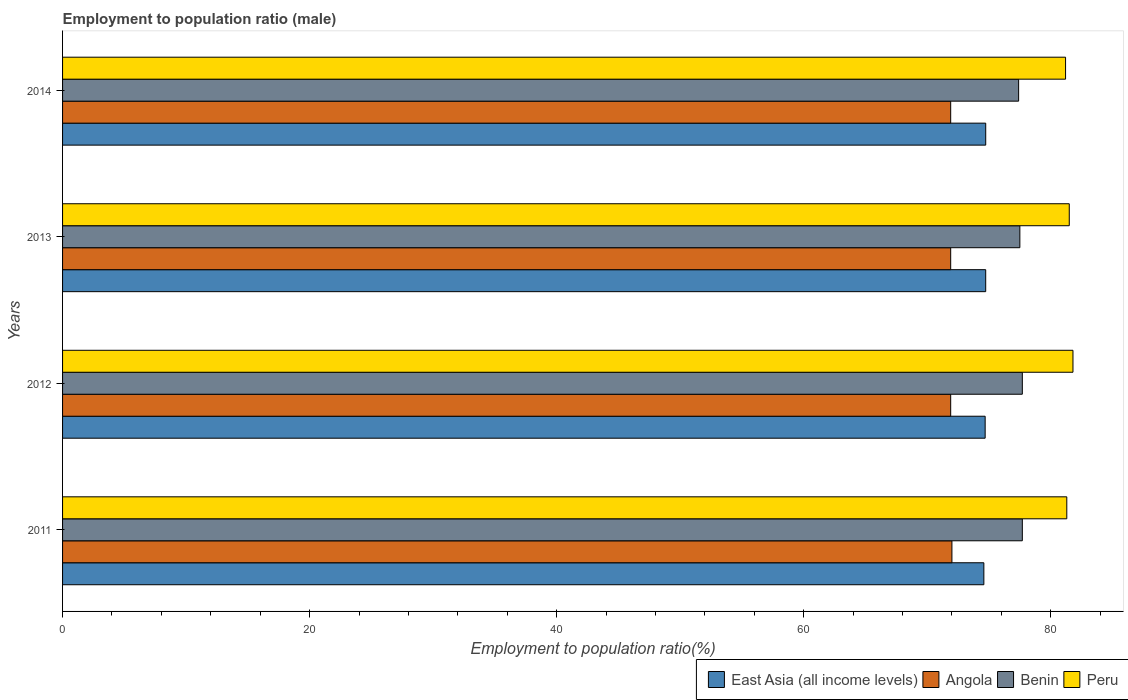What is the label of the 2nd group of bars from the top?
Your response must be concise. 2013. In how many cases, is the number of bars for a given year not equal to the number of legend labels?
Your response must be concise. 0. What is the employment to population ratio in Benin in 2014?
Give a very brief answer. 77.4. Across all years, what is the minimum employment to population ratio in Benin?
Provide a succinct answer. 77.4. In which year was the employment to population ratio in Benin maximum?
Provide a short and direct response. 2011. What is the total employment to population ratio in Peru in the graph?
Provide a succinct answer. 325.8. What is the difference between the employment to population ratio in East Asia (all income levels) in 2011 and that in 2013?
Provide a short and direct response. -0.15. What is the difference between the employment to population ratio in Angola in 2011 and the employment to population ratio in East Asia (all income levels) in 2012?
Give a very brief answer. -2.69. What is the average employment to population ratio in Angola per year?
Provide a succinct answer. 71.93. In the year 2012, what is the difference between the employment to population ratio in Peru and employment to population ratio in Angola?
Make the answer very short. 9.9. In how many years, is the employment to population ratio in Benin greater than 20 %?
Ensure brevity in your answer.  4. What is the difference between the highest and the second highest employment to population ratio in Peru?
Keep it short and to the point. 0.3. What is the difference between the highest and the lowest employment to population ratio in Angola?
Give a very brief answer. 0.1. Is the sum of the employment to population ratio in Benin in 2011 and 2013 greater than the maximum employment to population ratio in Peru across all years?
Offer a very short reply. Yes. Is it the case that in every year, the sum of the employment to population ratio in East Asia (all income levels) and employment to population ratio in Peru is greater than the sum of employment to population ratio in Angola and employment to population ratio in Benin?
Offer a very short reply. Yes. What does the 4th bar from the top in 2011 represents?
Your answer should be compact. East Asia (all income levels). What does the 3rd bar from the bottom in 2011 represents?
Offer a very short reply. Benin. Are all the bars in the graph horizontal?
Keep it short and to the point. Yes. How many years are there in the graph?
Give a very brief answer. 4. What is the difference between two consecutive major ticks on the X-axis?
Offer a very short reply. 20. Are the values on the major ticks of X-axis written in scientific E-notation?
Your response must be concise. No. Does the graph contain any zero values?
Provide a short and direct response. No. Where does the legend appear in the graph?
Provide a short and direct response. Bottom right. What is the title of the graph?
Provide a short and direct response. Employment to population ratio (male). Does "Bolivia" appear as one of the legend labels in the graph?
Offer a very short reply. No. What is the label or title of the X-axis?
Ensure brevity in your answer.  Employment to population ratio(%). What is the Employment to population ratio(%) in East Asia (all income levels) in 2011?
Make the answer very short. 74.59. What is the Employment to population ratio(%) in Angola in 2011?
Your answer should be very brief. 72. What is the Employment to population ratio(%) in Benin in 2011?
Give a very brief answer. 77.7. What is the Employment to population ratio(%) in Peru in 2011?
Provide a short and direct response. 81.3. What is the Employment to population ratio(%) of East Asia (all income levels) in 2012?
Make the answer very short. 74.69. What is the Employment to population ratio(%) in Angola in 2012?
Ensure brevity in your answer.  71.9. What is the Employment to population ratio(%) of Benin in 2012?
Make the answer very short. 77.7. What is the Employment to population ratio(%) of Peru in 2012?
Offer a very short reply. 81.8. What is the Employment to population ratio(%) of East Asia (all income levels) in 2013?
Keep it short and to the point. 74.74. What is the Employment to population ratio(%) in Angola in 2013?
Keep it short and to the point. 71.9. What is the Employment to population ratio(%) of Benin in 2013?
Your answer should be compact. 77.5. What is the Employment to population ratio(%) of Peru in 2013?
Provide a short and direct response. 81.5. What is the Employment to population ratio(%) of East Asia (all income levels) in 2014?
Your response must be concise. 74.74. What is the Employment to population ratio(%) in Angola in 2014?
Offer a very short reply. 71.9. What is the Employment to population ratio(%) of Benin in 2014?
Offer a terse response. 77.4. What is the Employment to population ratio(%) of Peru in 2014?
Ensure brevity in your answer.  81.2. Across all years, what is the maximum Employment to population ratio(%) in East Asia (all income levels)?
Your answer should be very brief. 74.74. Across all years, what is the maximum Employment to population ratio(%) of Benin?
Keep it short and to the point. 77.7. Across all years, what is the maximum Employment to population ratio(%) in Peru?
Offer a very short reply. 81.8. Across all years, what is the minimum Employment to population ratio(%) of East Asia (all income levels)?
Offer a very short reply. 74.59. Across all years, what is the minimum Employment to population ratio(%) of Angola?
Give a very brief answer. 71.9. Across all years, what is the minimum Employment to population ratio(%) in Benin?
Offer a very short reply. 77.4. Across all years, what is the minimum Employment to population ratio(%) in Peru?
Your response must be concise. 81.2. What is the total Employment to population ratio(%) in East Asia (all income levels) in the graph?
Your answer should be compact. 298.75. What is the total Employment to population ratio(%) of Angola in the graph?
Your answer should be compact. 287.7. What is the total Employment to population ratio(%) of Benin in the graph?
Offer a very short reply. 310.3. What is the total Employment to population ratio(%) in Peru in the graph?
Ensure brevity in your answer.  325.8. What is the difference between the Employment to population ratio(%) in East Asia (all income levels) in 2011 and that in 2012?
Make the answer very short. -0.1. What is the difference between the Employment to population ratio(%) in Angola in 2011 and that in 2012?
Give a very brief answer. 0.1. What is the difference between the Employment to population ratio(%) in Benin in 2011 and that in 2012?
Give a very brief answer. 0. What is the difference between the Employment to population ratio(%) of Peru in 2011 and that in 2012?
Your answer should be compact. -0.5. What is the difference between the Employment to population ratio(%) of East Asia (all income levels) in 2011 and that in 2013?
Offer a terse response. -0.15. What is the difference between the Employment to population ratio(%) in East Asia (all income levels) in 2011 and that in 2014?
Your answer should be compact. -0.15. What is the difference between the Employment to population ratio(%) of Angola in 2011 and that in 2014?
Offer a very short reply. 0.1. What is the difference between the Employment to population ratio(%) in Benin in 2011 and that in 2014?
Offer a very short reply. 0.3. What is the difference between the Employment to population ratio(%) in East Asia (all income levels) in 2012 and that in 2013?
Offer a very short reply. -0.05. What is the difference between the Employment to population ratio(%) in Peru in 2012 and that in 2013?
Offer a very short reply. 0.3. What is the difference between the Employment to population ratio(%) of East Asia (all income levels) in 2012 and that in 2014?
Provide a short and direct response. -0.05. What is the difference between the Employment to population ratio(%) in Angola in 2012 and that in 2014?
Give a very brief answer. 0. What is the difference between the Employment to population ratio(%) in East Asia (all income levels) in 2013 and that in 2014?
Keep it short and to the point. -0. What is the difference between the Employment to population ratio(%) of Angola in 2013 and that in 2014?
Provide a short and direct response. 0. What is the difference between the Employment to population ratio(%) of East Asia (all income levels) in 2011 and the Employment to population ratio(%) of Angola in 2012?
Your answer should be compact. 2.69. What is the difference between the Employment to population ratio(%) of East Asia (all income levels) in 2011 and the Employment to population ratio(%) of Benin in 2012?
Your response must be concise. -3.11. What is the difference between the Employment to population ratio(%) of East Asia (all income levels) in 2011 and the Employment to population ratio(%) of Peru in 2012?
Ensure brevity in your answer.  -7.21. What is the difference between the Employment to population ratio(%) in Angola in 2011 and the Employment to population ratio(%) in Benin in 2012?
Provide a short and direct response. -5.7. What is the difference between the Employment to population ratio(%) of Angola in 2011 and the Employment to population ratio(%) of Peru in 2012?
Provide a succinct answer. -9.8. What is the difference between the Employment to population ratio(%) of East Asia (all income levels) in 2011 and the Employment to population ratio(%) of Angola in 2013?
Make the answer very short. 2.69. What is the difference between the Employment to population ratio(%) of East Asia (all income levels) in 2011 and the Employment to population ratio(%) of Benin in 2013?
Ensure brevity in your answer.  -2.91. What is the difference between the Employment to population ratio(%) of East Asia (all income levels) in 2011 and the Employment to population ratio(%) of Peru in 2013?
Offer a very short reply. -6.91. What is the difference between the Employment to population ratio(%) of East Asia (all income levels) in 2011 and the Employment to population ratio(%) of Angola in 2014?
Offer a very short reply. 2.69. What is the difference between the Employment to population ratio(%) of East Asia (all income levels) in 2011 and the Employment to population ratio(%) of Benin in 2014?
Make the answer very short. -2.81. What is the difference between the Employment to population ratio(%) of East Asia (all income levels) in 2011 and the Employment to population ratio(%) of Peru in 2014?
Provide a short and direct response. -6.61. What is the difference between the Employment to population ratio(%) of Angola in 2011 and the Employment to population ratio(%) of Benin in 2014?
Your answer should be very brief. -5.4. What is the difference between the Employment to population ratio(%) in East Asia (all income levels) in 2012 and the Employment to population ratio(%) in Angola in 2013?
Your response must be concise. 2.79. What is the difference between the Employment to population ratio(%) of East Asia (all income levels) in 2012 and the Employment to population ratio(%) of Benin in 2013?
Make the answer very short. -2.81. What is the difference between the Employment to population ratio(%) of East Asia (all income levels) in 2012 and the Employment to population ratio(%) of Peru in 2013?
Offer a terse response. -6.81. What is the difference between the Employment to population ratio(%) in East Asia (all income levels) in 2012 and the Employment to population ratio(%) in Angola in 2014?
Keep it short and to the point. 2.79. What is the difference between the Employment to population ratio(%) of East Asia (all income levels) in 2012 and the Employment to population ratio(%) of Benin in 2014?
Make the answer very short. -2.71. What is the difference between the Employment to population ratio(%) in East Asia (all income levels) in 2012 and the Employment to population ratio(%) in Peru in 2014?
Offer a very short reply. -6.51. What is the difference between the Employment to population ratio(%) in Angola in 2012 and the Employment to population ratio(%) in Benin in 2014?
Make the answer very short. -5.5. What is the difference between the Employment to population ratio(%) of East Asia (all income levels) in 2013 and the Employment to population ratio(%) of Angola in 2014?
Offer a very short reply. 2.84. What is the difference between the Employment to population ratio(%) of East Asia (all income levels) in 2013 and the Employment to population ratio(%) of Benin in 2014?
Provide a short and direct response. -2.66. What is the difference between the Employment to population ratio(%) of East Asia (all income levels) in 2013 and the Employment to population ratio(%) of Peru in 2014?
Keep it short and to the point. -6.46. What is the difference between the Employment to population ratio(%) in Angola in 2013 and the Employment to population ratio(%) in Peru in 2014?
Keep it short and to the point. -9.3. What is the difference between the Employment to population ratio(%) in Benin in 2013 and the Employment to population ratio(%) in Peru in 2014?
Give a very brief answer. -3.7. What is the average Employment to population ratio(%) in East Asia (all income levels) per year?
Your answer should be very brief. 74.69. What is the average Employment to population ratio(%) of Angola per year?
Your answer should be compact. 71.92. What is the average Employment to population ratio(%) of Benin per year?
Keep it short and to the point. 77.58. What is the average Employment to population ratio(%) in Peru per year?
Provide a short and direct response. 81.45. In the year 2011, what is the difference between the Employment to population ratio(%) of East Asia (all income levels) and Employment to population ratio(%) of Angola?
Offer a terse response. 2.59. In the year 2011, what is the difference between the Employment to population ratio(%) in East Asia (all income levels) and Employment to population ratio(%) in Benin?
Offer a terse response. -3.11. In the year 2011, what is the difference between the Employment to population ratio(%) of East Asia (all income levels) and Employment to population ratio(%) of Peru?
Ensure brevity in your answer.  -6.71. In the year 2011, what is the difference between the Employment to population ratio(%) of Angola and Employment to population ratio(%) of Peru?
Make the answer very short. -9.3. In the year 2012, what is the difference between the Employment to population ratio(%) in East Asia (all income levels) and Employment to population ratio(%) in Angola?
Make the answer very short. 2.79. In the year 2012, what is the difference between the Employment to population ratio(%) in East Asia (all income levels) and Employment to population ratio(%) in Benin?
Keep it short and to the point. -3.01. In the year 2012, what is the difference between the Employment to population ratio(%) of East Asia (all income levels) and Employment to population ratio(%) of Peru?
Your response must be concise. -7.11. In the year 2013, what is the difference between the Employment to population ratio(%) in East Asia (all income levels) and Employment to population ratio(%) in Angola?
Keep it short and to the point. 2.84. In the year 2013, what is the difference between the Employment to population ratio(%) of East Asia (all income levels) and Employment to population ratio(%) of Benin?
Your answer should be very brief. -2.76. In the year 2013, what is the difference between the Employment to population ratio(%) in East Asia (all income levels) and Employment to population ratio(%) in Peru?
Your response must be concise. -6.76. In the year 2014, what is the difference between the Employment to population ratio(%) of East Asia (all income levels) and Employment to population ratio(%) of Angola?
Your answer should be compact. 2.84. In the year 2014, what is the difference between the Employment to population ratio(%) of East Asia (all income levels) and Employment to population ratio(%) of Benin?
Your answer should be very brief. -2.66. In the year 2014, what is the difference between the Employment to population ratio(%) of East Asia (all income levels) and Employment to population ratio(%) of Peru?
Ensure brevity in your answer.  -6.46. In the year 2014, what is the difference between the Employment to population ratio(%) of Angola and Employment to population ratio(%) of Benin?
Provide a succinct answer. -5.5. In the year 2014, what is the difference between the Employment to population ratio(%) of Angola and Employment to population ratio(%) of Peru?
Offer a terse response. -9.3. What is the ratio of the Employment to population ratio(%) in East Asia (all income levels) in 2011 to that in 2013?
Offer a terse response. 1. What is the ratio of the Employment to population ratio(%) of Angola in 2011 to that in 2013?
Keep it short and to the point. 1. What is the ratio of the Employment to population ratio(%) of Benin in 2011 to that in 2013?
Your response must be concise. 1. What is the ratio of the Employment to population ratio(%) of Angola in 2011 to that in 2014?
Ensure brevity in your answer.  1. What is the ratio of the Employment to population ratio(%) of Benin in 2011 to that in 2014?
Make the answer very short. 1. What is the ratio of the Employment to population ratio(%) of Peru in 2011 to that in 2014?
Ensure brevity in your answer.  1. What is the ratio of the Employment to population ratio(%) of Angola in 2012 to that in 2013?
Offer a terse response. 1. What is the ratio of the Employment to population ratio(%) in Peru in 2012 to that in 2013?
Your answer should be very brief. 1. What is the ratio of the Employment to population ratio(%) in East Asia (all income levels) in 2012 to that in 2014?
Offer a very short reply. 1. What is the ratio of the Employment to population ratio(%) of Peru in 2012 to that in 2014?
Offer a terse response. 1.01. What is the ratio of the Employment to population ratio(%) of Angola in 2013 to that in 2014?
Ensure brevity in your answer.  1. What is the ratio of the Employment to population ratio(%) of Benin in 2013 to that in 2014?
Provide a short and direct response. 1. What is the ratio of the Employment to population ratio(%) in Peru in 2013 to that in 2014?
Provide a succinct answer. 1. What is the difference between the highest and the second highest Employment to population ratio(%) of East Asia (all income levels)?
Give a very brief answer. 0. What is the difference between the highest and the second highest Employment to population ratio(%) of Angola?
Provide a short and direct response. 0.1. What is the difference between the highest and the second highest Employment to population ratio(%) in Peru?
Ensure brevity in your answer.  0.3. What is the difference between the highest and the lowest Employment to population ratio(%) of East Asia (all income levels)?
Make the answer very short. 0.15. What is the difference between the highest and the lowest Employment to population ratio(%) in Angola?
Your answer should be compact. 0.1. What is the difference between the highest and the lowest Employment to population ratio(%) in Benin?
Provide a short and direct response. 0.3. What is the difference between the highest and the lowest Employment to population ratio(%) of Peru?
Your response must be concise. 0.6. 